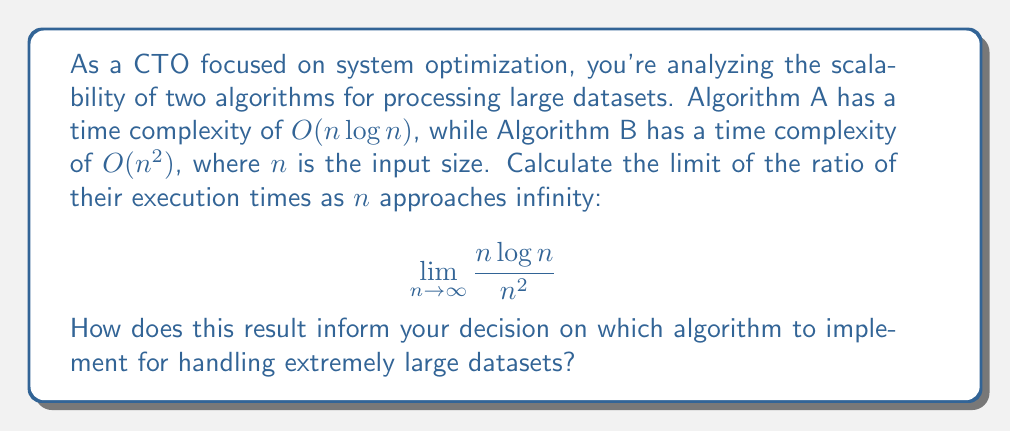Teach me how to tackle this problem. Let's approach this step-by-step:

1) We need to calculate $\lim_{n \to \infty} \frac{n\log n}{n^2}$.

2) To solve this, we can use L'Hôpital's rule, as both numerator and denominator approach infinity as $n \to \infty$.

3) L'Hôpital's rule states that for functions $f(x)$ and $g(x)$:

   $$\lim_{x \to \infty} \frac{f(x)}{g(x)} = \lim_{x \to \infty} \frac{f'(x)}{g'(x)}$$

   if this limit exists.

4) Let's differentiate the numerator and denominator separately:

   Numerator: $\frac{d}{dn}(n\log n) = \log n + n \cdot \frac{1}{n} = \log n + 1$
   
   Denominator: $\frac{d}{dn}(n^2) = 2n$

5) Now our limit becomes:

   $$\lim_{n \to \infty} \frac{\log n + 1}{2n}$$

6) We can apply L'Hôpital's rule again:

   Numerator: $\frac{d}{dn}(\log n + 1) = \frac{1}{n}$
   
   Denominator: $\frac{d}{dn}(2n) = 2$

7) Our limit is now:

   $$\lim_{n \to \infty} \frac{1/n}{2} = \lim_{n \to \infty} \frac{1}{2n} = 0$$

This result indicates that as $n$ approaches infinity, the ratio of the execution times of Algorithm A to Algorithm B approaches 0. In other words, Algorithm A (with $O(n\log n)$ complexity) becomes infinitely faster than Algorithm B (with $O(n^2)$ complexity) for extremely large datasets.
Answer: 0 